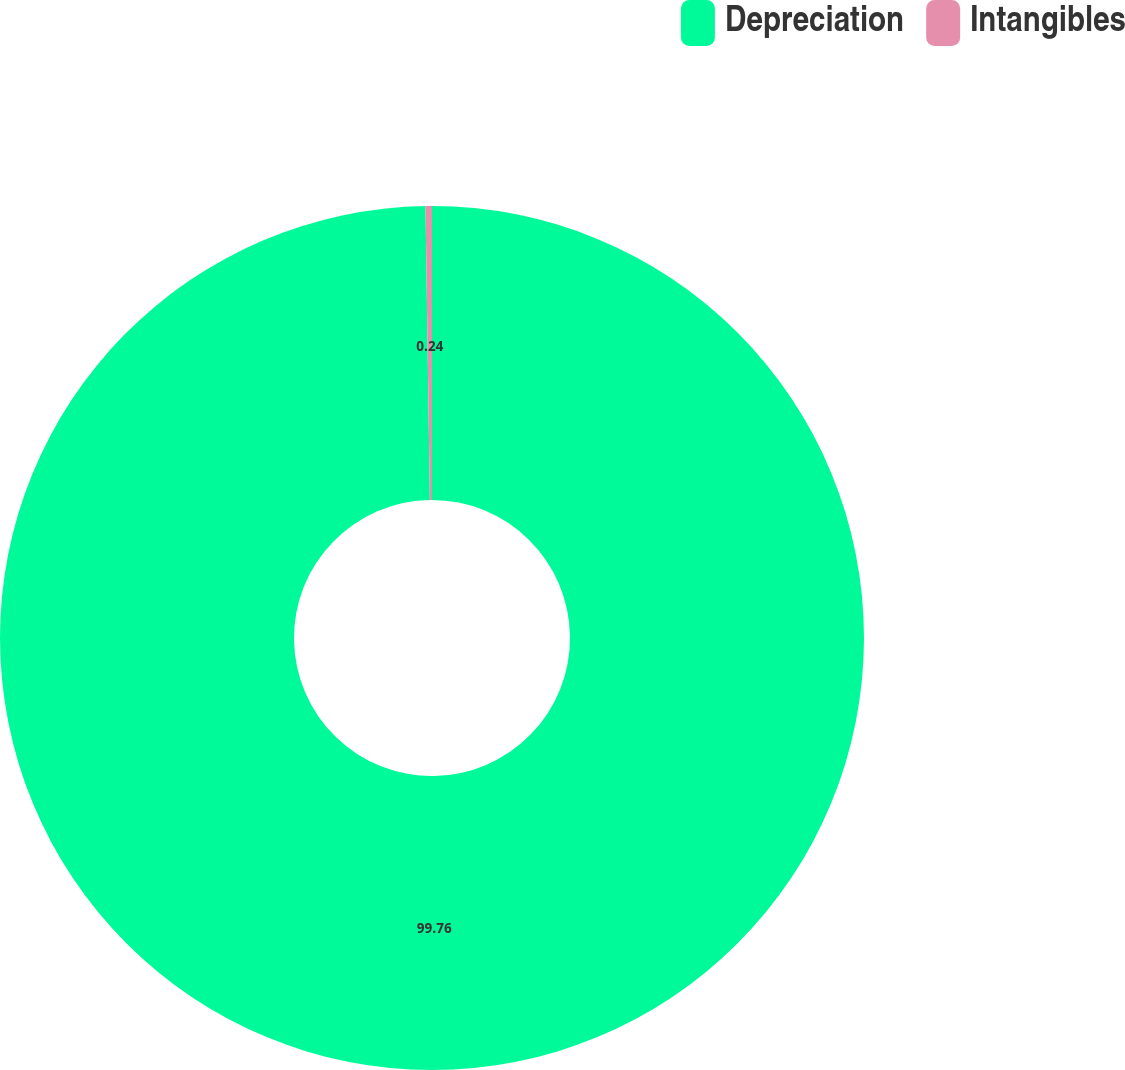Convert chart. <chart><loc_0><loc_0><loc_500><loc_500><pie_chart><fcel>Depreciation<fcel>Intangibles<nl><fcel>99.76%<fcel>0.24%<nl></chart> 